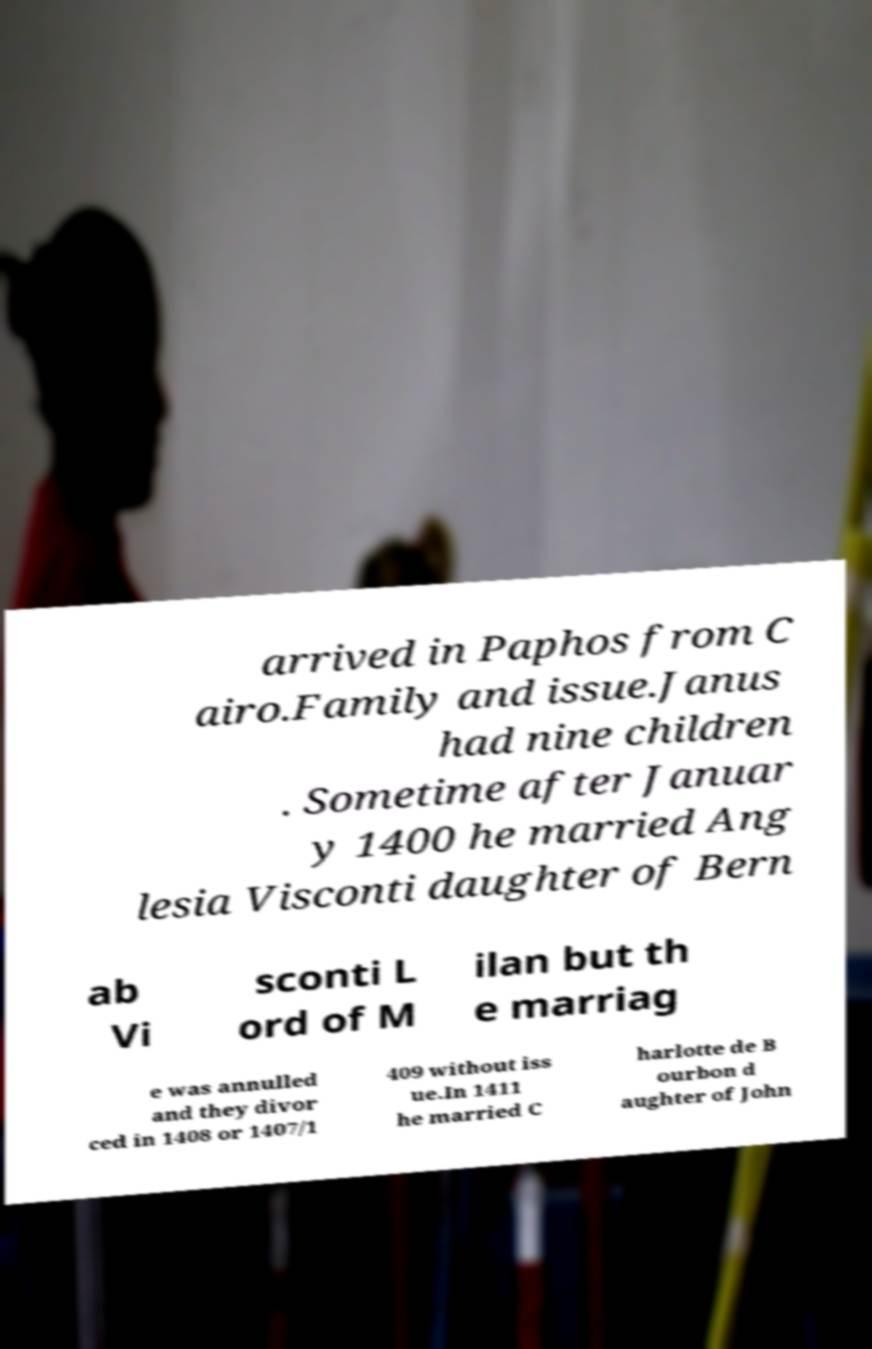What messages or text are displayed in this image? I need them in a readable, typed format. arrived in Paphos from C airo.Family and issue.Janus had nine children . Sometime after Januar y 1400 he married Ang lesia Visconti daughter of Bern ab Vi sconti L ord of M ilan but th e marriag e was annulled and they divor ced in 1408 or 1407/1 409 without iss ue.In 1411 he married C harlotte de B ourbon d aughter of John 